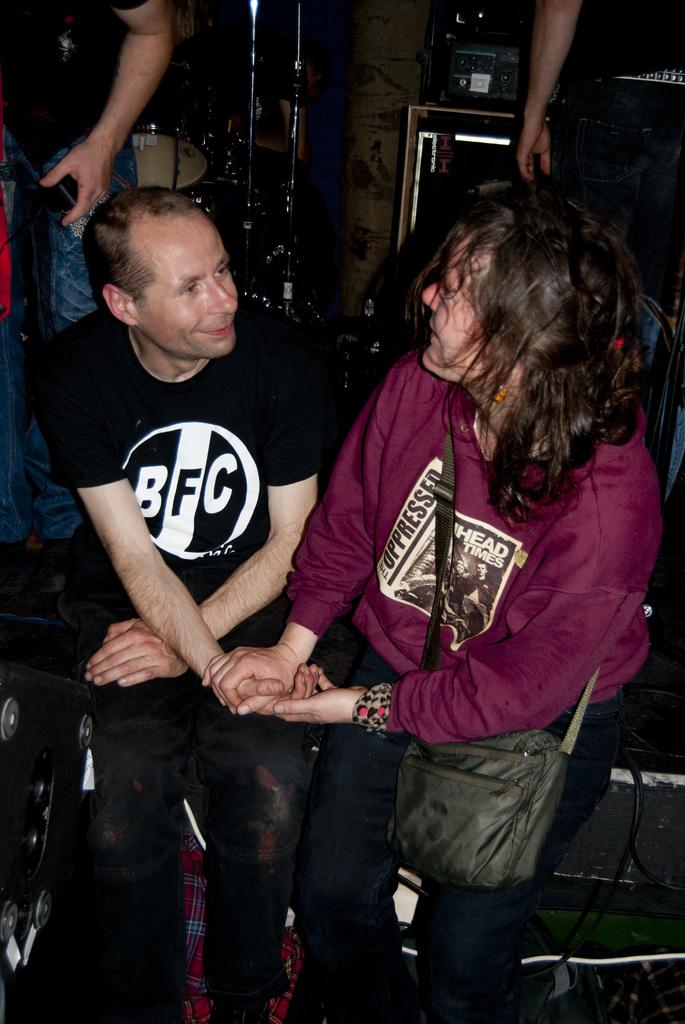<image>
Write a terse but informative summary of the picture. A man with a BFC shirt holds hands with another person. 